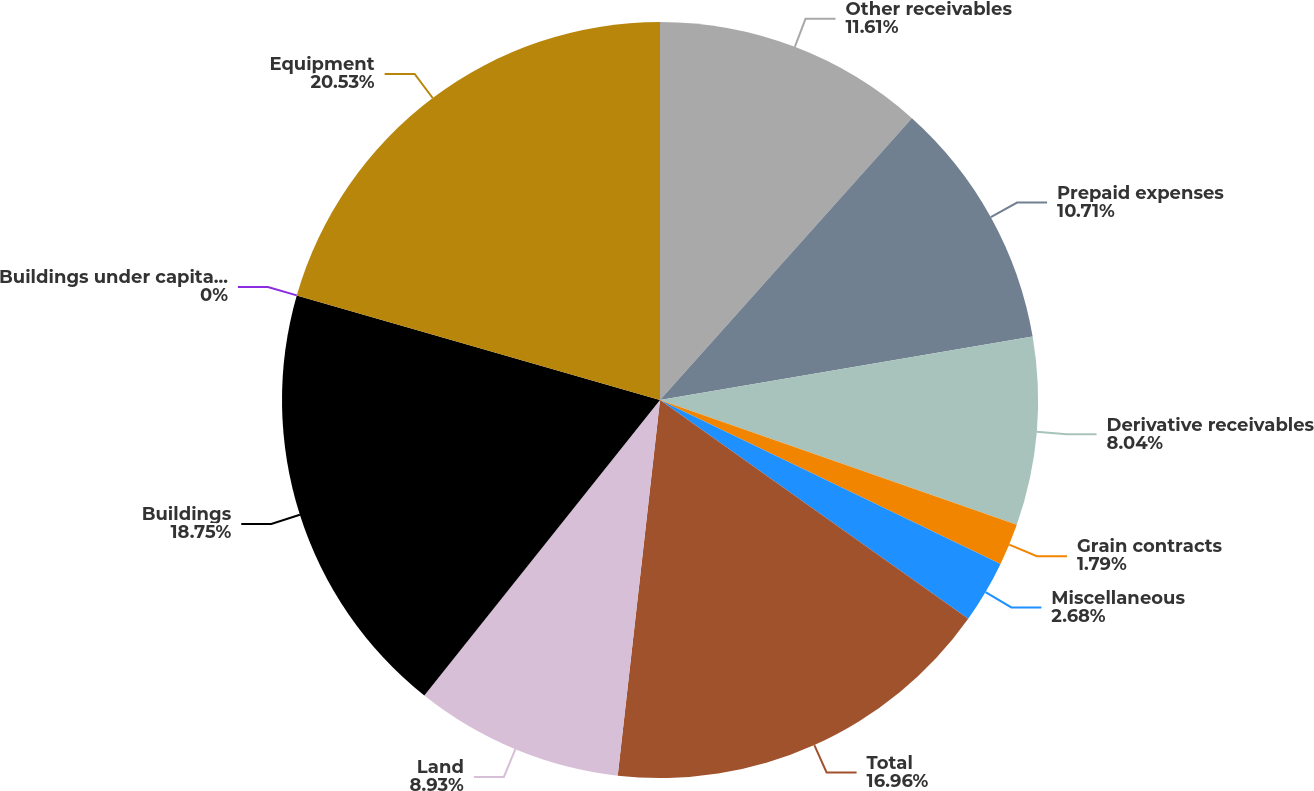Convert chart to OTSL. <chart><loc_0><loc_0><loc_500><loc_500><pie_chart><fcel>Other receivables<fcel>Prepaid expenses<fcel>Derivative receivables<fcel>Grain contracts<fcel>Miscellaneous<fcel>Total<fcel>Land<fcel>Buildings<fcel>Buildings under capital lease<fcel>Equipment<nl><fcel>11.61%<fcel>10.71%<fcel>8.04%<fcel>1.79%<fcel>2.68%<fcel>16.96%<fcel>8.93%<fcel>18.75%<fcel>0.0%<fcel>20.54%<nl></chart> 